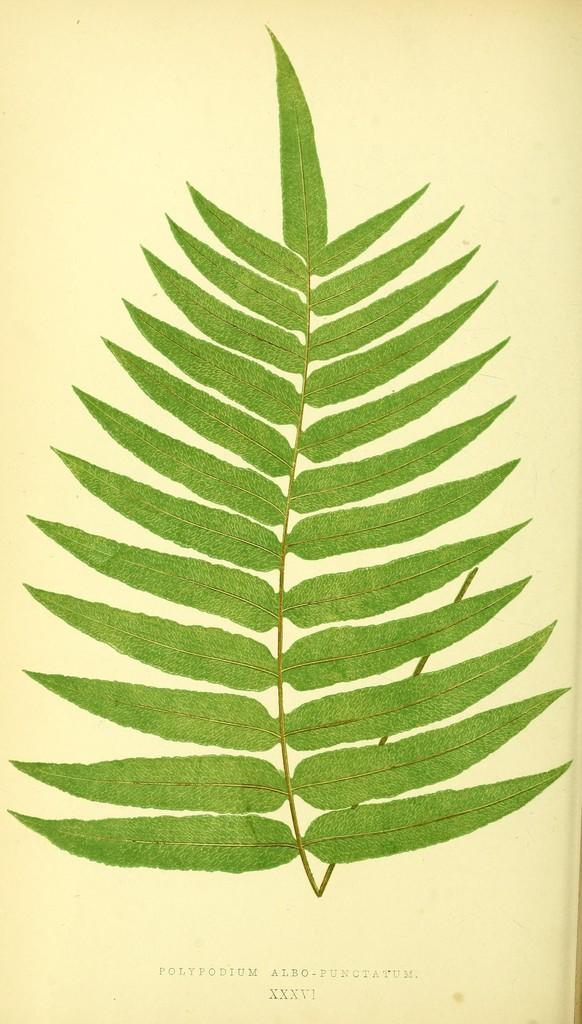What type of visual is the image? The image is a poster. What is depicted on the poster? There are depictions of leafs on the poster. Where is the text located on the poster? The text is at the bottom of the poster. What does your mom say about the mine in the image? There is no mention of a mine or your mom in the image, as it only features depictions of leafs and text. 